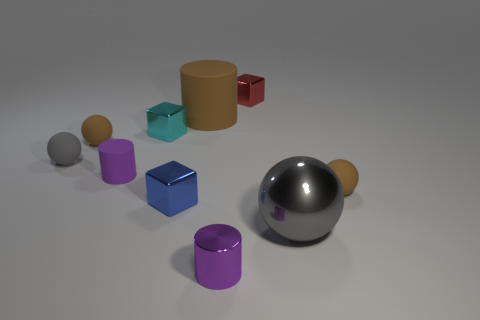Subtract 1 spheres. How many spheres are left? 3 Subtract all red balls. Subtract all cyan cylinders. How many balls are left? 4 Subtract all cylinders. How many objects are left? 7 Add 9 tiny gray rubber balls. How many tiny gray rubber balls are left? 10 Add 4 red matte blocks. How many red matte blocks exist? 4 Subtract 0 green cylinders. How many objects are left? 10 Subtract all large brown objects. Subtract all purple rubber cylinders. How many objects are left? 8 